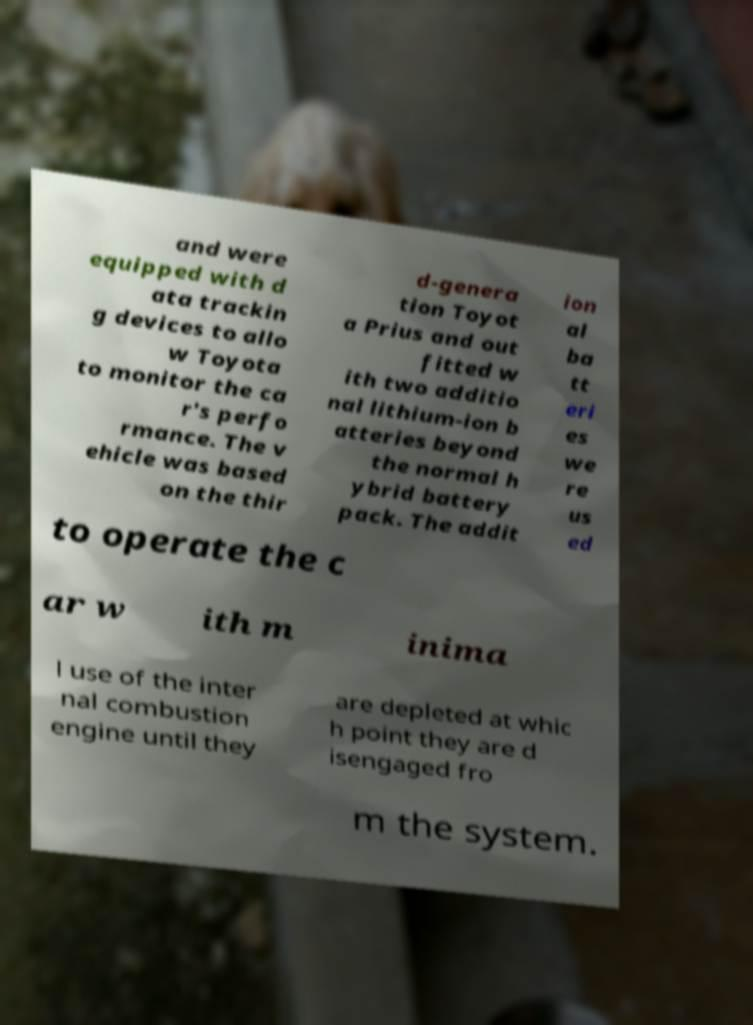Please identify and transcribe the text found in this image. and were equipped with d ata trackin g devices to allo w Toyota to monitor the ca r's perfo rmance. The v ehicle was based on the thir d-genera tion Toyot a Prius and out fitted w ith two additio nal lithium-ion b atteries beyond the normal h ybrid battery pack. The addit ion al ba tt eri es we re us ed to operate the c ar w ith m inima l use of the inter nal combustion engine until they are depleted at whic h point they are d isengaged fro m the system. 